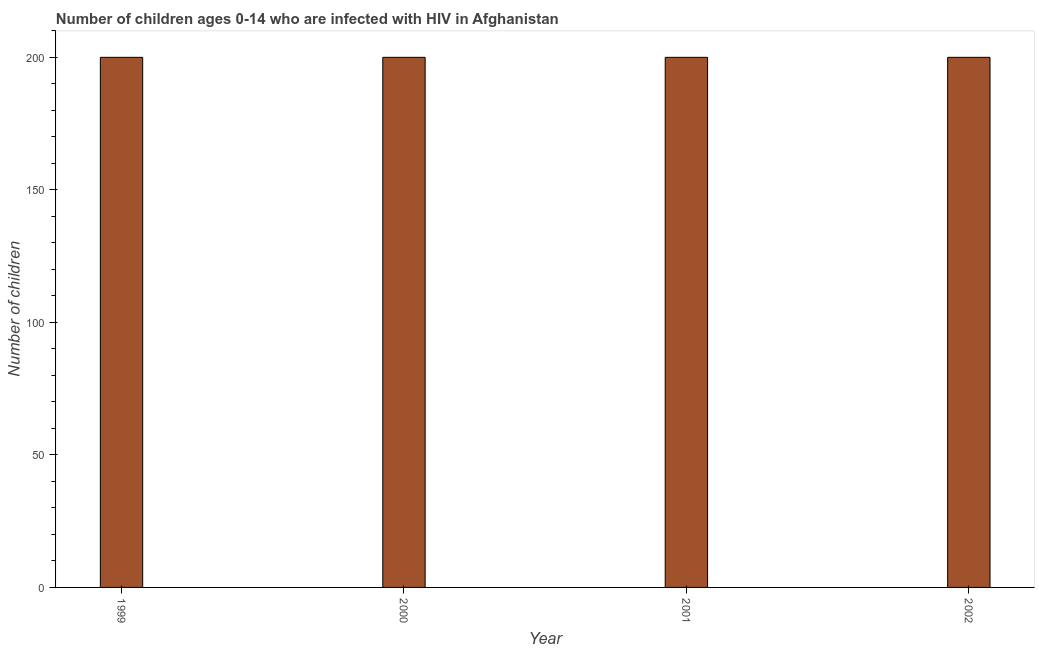Does the graph contain any zero values?
Offer a terse response. No. Does the graph contain grids?
Keep it short and to the point. No. What is the title of the graph?
Make the answer very short. Number of children ages 0-14 who are infected with HIV in Afghanistan. What is the label or title of the X-axis?
Your answer should be very brief. Year. What is the label or title of the Y-axis?
Offer a terse response. Number of children. What is the number of children living with hiv in 2001?
Your answer should be very brief. 200. Across all years, what is the minimum number of children living with hiv?
Make the answer very short. 200. In which year was the number of children living with hiv maximum?
Offer a very short reply. 1999. In which year was the number of children living with hiv minimum?
Ensure brevity in your answer.  1999. What is the sum of the number of children living with hiv?
Make the answer very short. 800. What is the difference between the number of children living with hiv in 1999 and 2001?
Provide a succinct answer. 0. Do a majority of the years between 2002 and 2000 (inclusive) have number of children living with hiv greater than 80 ?
Provide a short and direct response. Yes. What is the ratio of the number of children living with hiv in 1999 to that in 2002?
Give a very brief answer. 1. How many bars are there?
Your response must be concise. 4. Are all the bars in the graph horizontal?
Keep it short and to the point. No. How many years are there in the graph?
Ensure brevity in your answer.  4. What is the difference between two consecutive major ticks on the Y-axis?
Your response must be concise. 50. Are the values on the major ticks of Y-axis written in scientific E-notation?
Ensure brevity in your answer.  No. What is the Number of children in 2000?
Ensure brevity in your answer.  200. What is the difference between the Number of children in 1999 and 2000?
Give a very brief answer. 0. What is the difference between the Number of children in 2001 and 2002?
Make the answer very short. 0. What is the ratio of the Number of children in 1999 to that in 2000?
Keep it short and to the point. 1. What is the ratio of the Number of children in 1999 to that in 2001?
Your response must be concise. 1. What is the ratio of the Number of children in 2001 to that in 2002?
Give a very brief answer. 1. 